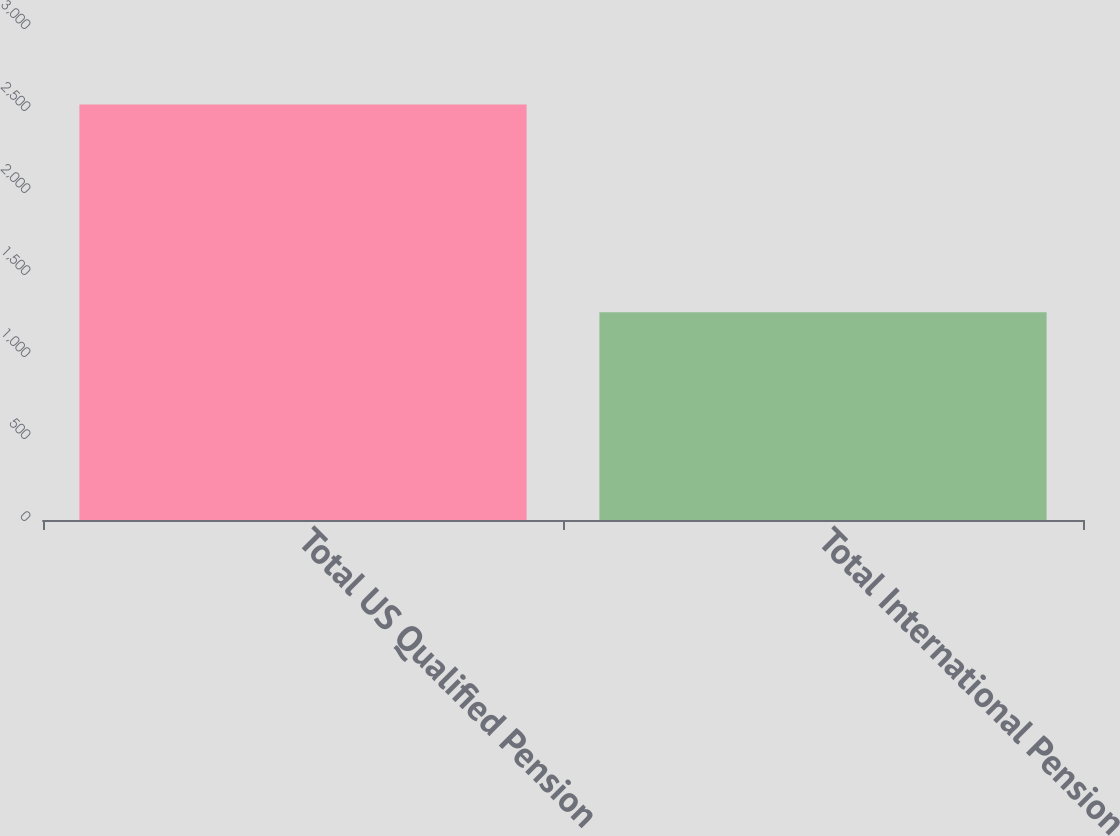Convert chart. <chart><loc_0><loc_0><loc_500><loc_500><bar_chart><fcel>Total US Qualified Pension<fcel>Total International Pension<nl><fcel>2534.2<fcel>1266.6<nl></chart> 